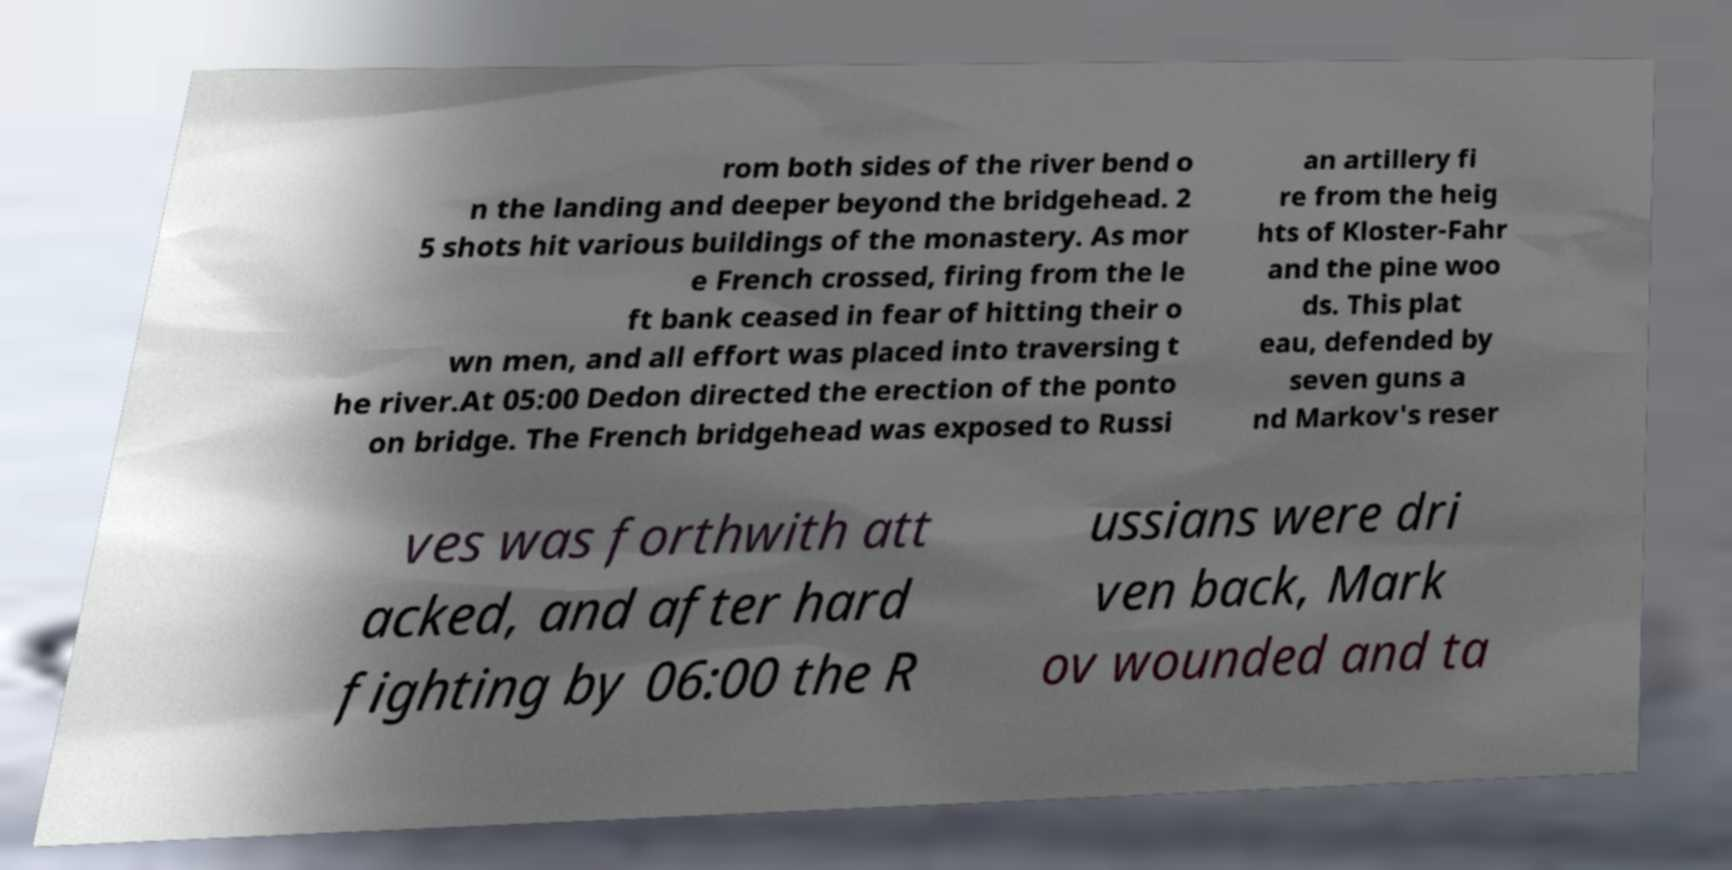I need the written content from this picture converted into text. Can you do that? rom both sides of the river bend o n the landing and deeper beyond the bridgehead. 2 5 shots hit various buildings of the monastery. As mor e French crossed, firing from the le ft bank ceased in fear of hitting their o wn men, and all effort was placed into traversing t he river.At 05:00 Dedon directed the erection of the ponto on bridge. The French bridgehead was exposed to Russi an artillery fi re from the heig hts of Kloster-Fahr and the pine woo ds. This plat eau, defended by seven guns a nd Markov's reser ves was forthwith att acked, and after hard fighting by 06:00 the R ussians were dri ven back, Mark ov wounded and ta 